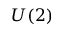<formula> <loc_0><loc_0><loc_500><loc_500>U ( 2 )</formula> 